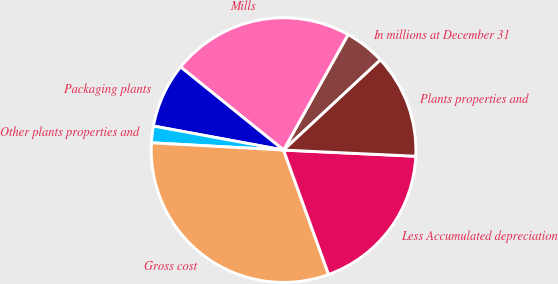Convert chart to OTSL. <chart><loc_0><loc_0><loc_500><loc_500><pie_chart><fcel>In millions at December 31<fcel>Mills<fcel>Packaging plants<fcel>Other plants properties and<fcel>Gross cost<fcel>Less Accumulated depreciation<fcel>Plants properties and<nl><fcel>4.96%<fcel>22.3%<fcel>7.9%<fcel>2.03%<fcel>31.4%<fcel>18.73%<fcel>12.67%<nl></chart> 